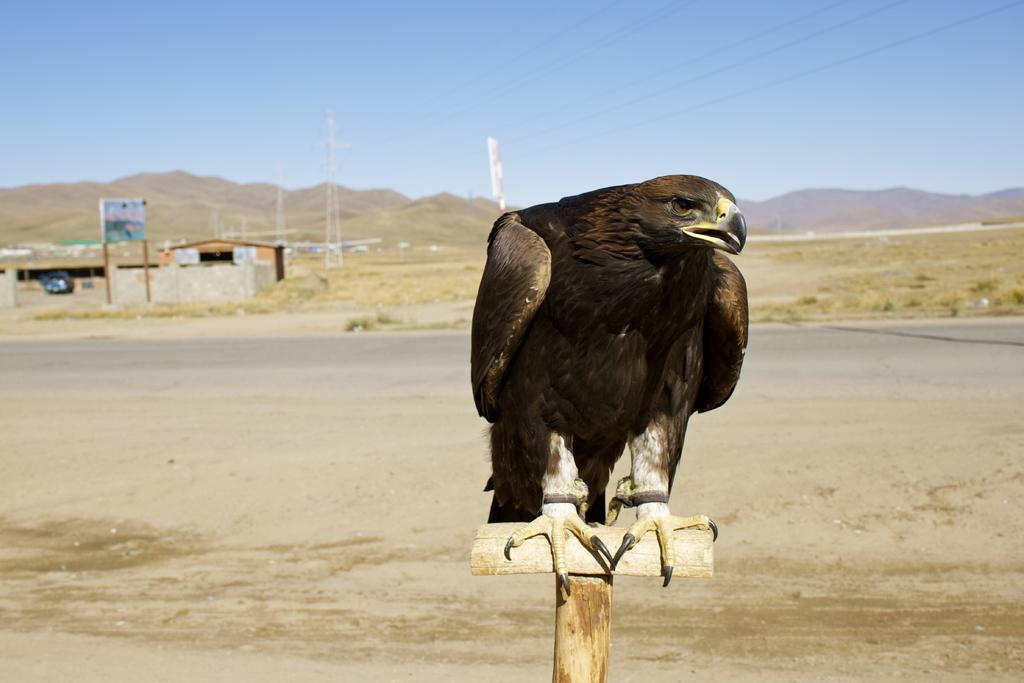What animal is featured in the image? There is an eagle in the image. What is the eagle sitting on? The eagle is sitting on a wooden stick. What can be seen in the background of the image? There is a building and towers with wires in the background. What is the condition of the sky in the image? The sky is clear in the image. Where is the fifth bedroom located in the image? There is no mention of a bedroom or any specific number of bedrooms in the image; it features an eagle sitting on a wooden stick with a background of a building and towers with wires. What type of trousers is the eagle wearing in the image? Eagles do not wear trousers, as they are birds and not human. 